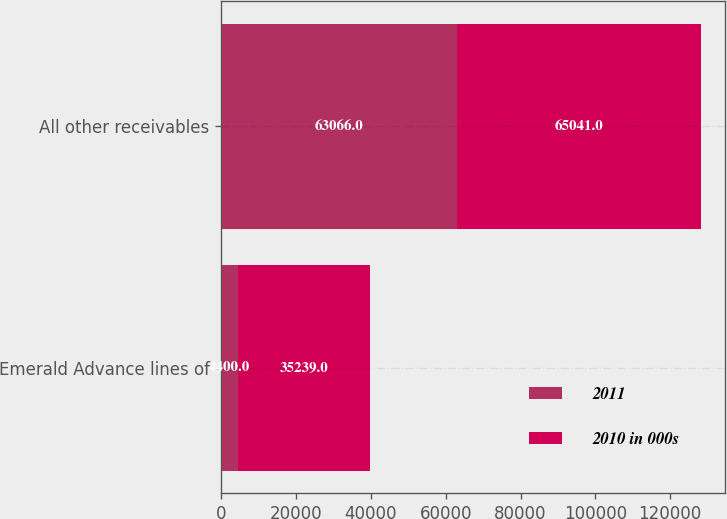Convert chart to OTSL. <chart><loc_0><loc_0><loc_500><loc_500><stacked_bar_chart><ecel><fcel>Emerald Advance lines of<fcel>All other receivables<nl><fcel>2011<fcel>4400<fcel>63066<nl><fcel>2010 in 000s<fcel>35239<fcel>65041<nl></chart> 